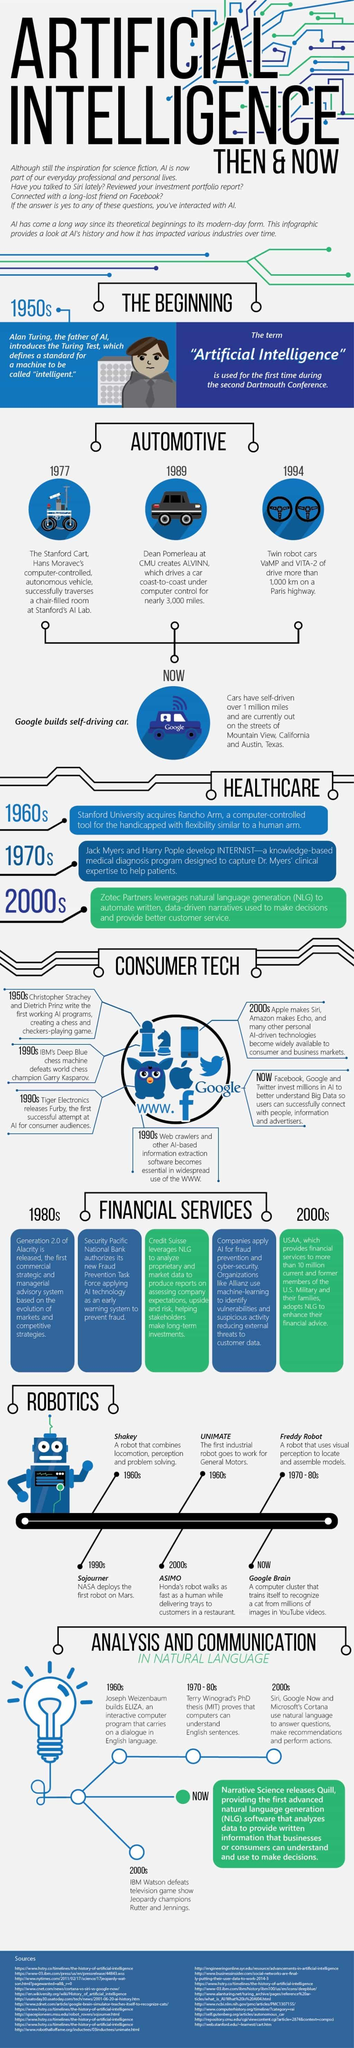Point out several critical features in this image. Christopher Strachey and Dietrich Prinz created the AI program that developed a chess and checkers-playing game. Freddy Robot, a robot developed in the '70s, was capable of locating and assembling models using visual perception. The first robot to travel to Mars was Sojourner, which was launched on July 4, 1997. The English conversation computer program created in the '60s, known as ELIZA, remains a notable example of early artificial intelligence technology. Shakey, the perceptive and problem-solving robot created in the 1960s, is a notable example of its kind. 